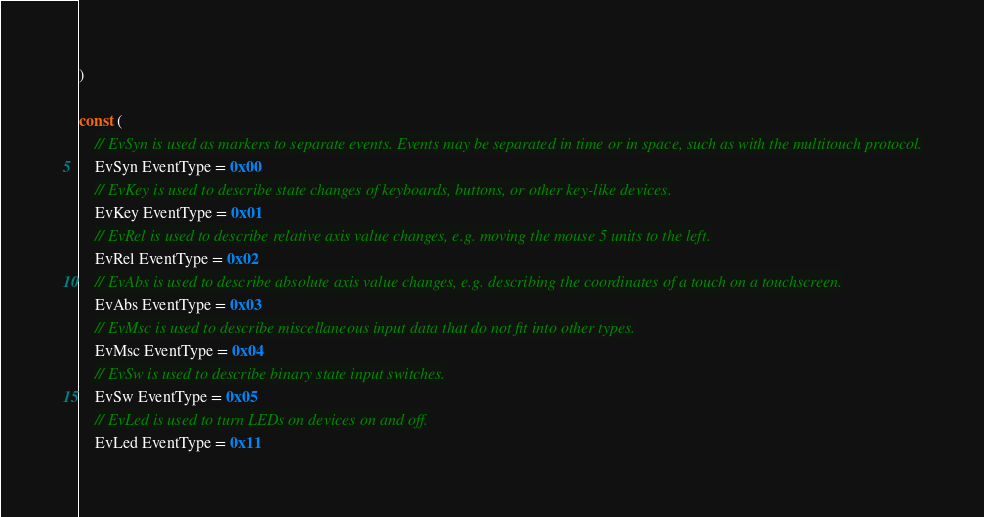Convert code to text. <code><loc_0><loc_0><loc_500><loc_500><_Go_>)

const (
	// EvSyn is used as markers to separate events. Events may be separated in time or in space, such as with the multitouch protocol.
	EvSyn EventType = 0x00
	// EvKey is used to describe state changes of keyboards, buttons, or other key-like devices.
	EvKey EventType = 0x01
	// EvRel is used to describe relative axis value changes, e.g. moving the mouse 5 units to the left.
	EvRel EventType = 0x02
	// EvAbs is used to describe absolute axis value changes, e.g. describing the coordinates of a touch on a touchscreen.
	EvAbs EventType = 0x03
	// EvMsc is used to describe miscellaneous input data that do not fit into other types.
	EvMsc EventType = 0x04
	// EvSw is used to describe binary state input switches.
	EvSw EventType = 0x05
	// EvLed is used to turn LEDs on devices on and off.
	EvLed EventType = 0x11</code> 